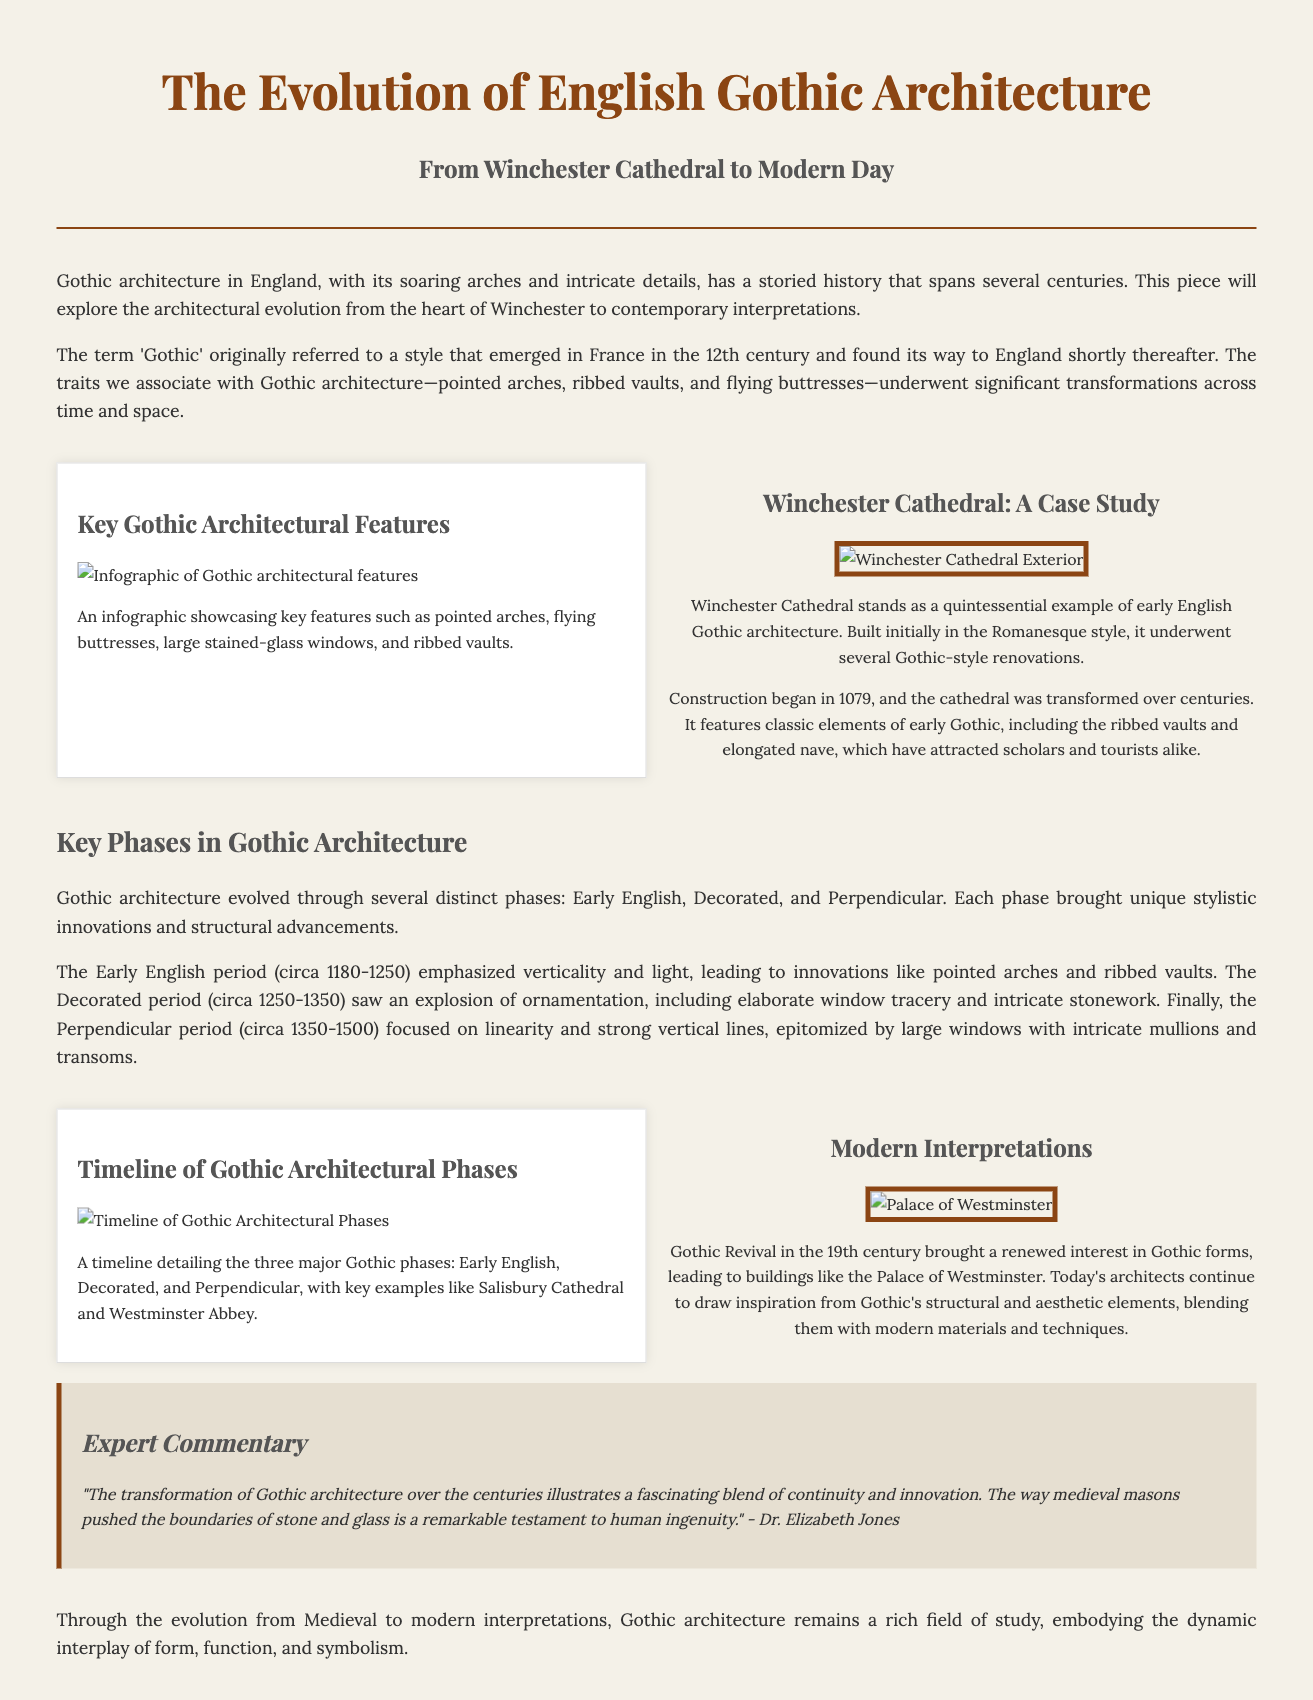what architectural style is the focus of the article? The article discusses the evolution of Gothic architecture in England.
Answer: Gothic architecture which cathedral is highlighted as a case study? The document mentions Winchester Cathedral as a key example of Gothic architecture.
Answer: Winchester Cathedral what are the three major Gothic phases mentioned? The timeline presents the Early English, Decorated, and Perpendicular phases.
Answer: Early English, Decorated, Perpendicular who provided expert commentary in the article? The expert commentary is attributed to Dr. Elizabeth Jones.
Answer: Dr. Elizabeth Jones what year did the construction of Winchester Cathedral begin? The document states that construction commenced in 1079.
Answer: 1079 which modern building is cited as a Gothic Revival example? The Palace of Westminster is identified as an example of modern Gothic architecture.
Answer: Palace of Westminster what feature was highlighted in the infographic about Gothic architecture? The infographic showcases features such as pointed arches and flying buttresses.
Answer: pointed arches, flying buttresses what period is associated with an emphasis on verticality and light? The Early English period (circa 1180-1250) is known for its emphasis on verticality and light.
Answer: Early English period what is the primary color used for headings in the document? The document uses a brownish color (specified as #8b4513) for headings.
Answer: #8b4513 